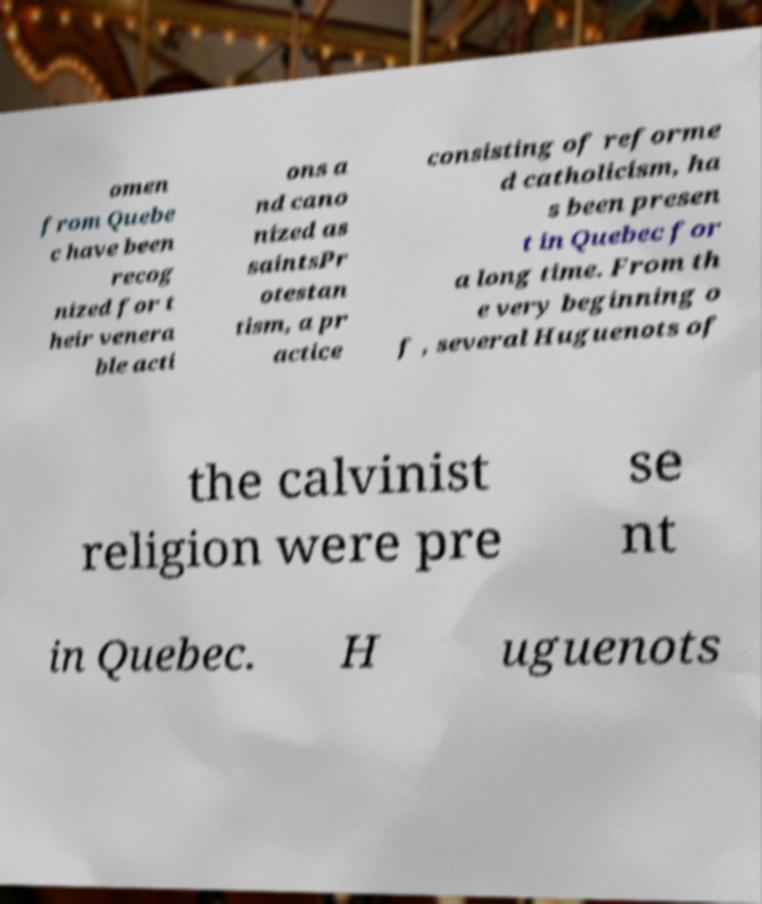Could you extract and type out the text from this image? omen from Quebe c have been recog nized for t heir venera ble acti ons a nd cano nized as saintsPr otestan tism, a pr actice consisting of reforme d catholicism, ha s been presen t in Quebec for a long time. From th e very beginning o f , several Huguenots of the calvinist religion were pre se nt in Quebec. H uguenots 